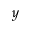Convert formula to latex. <formula><loc_0><loc_0><loc_500><loc_500>y</formula> 